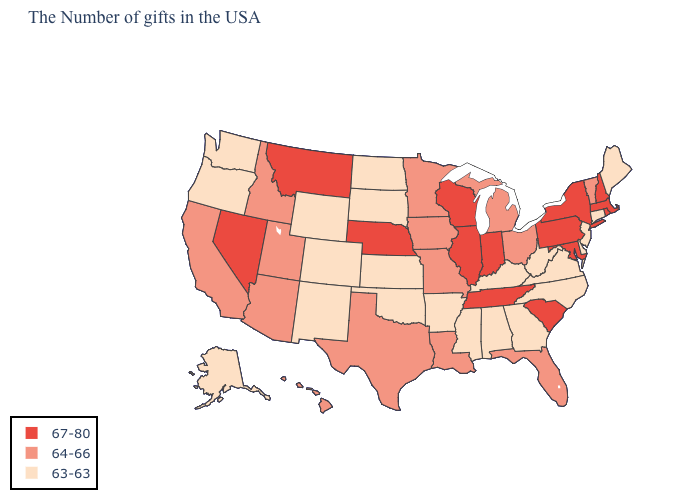What is the highest value in the USA?
Concise answer only. 67-80. What is the lowest value in the USA?
Give a very brief answer. 63-63. What is the value of Delaware?
Answer briefly. 63-63. Name the states that have a value in the range 63-63?
Write a very short answer. Maine, Connecticut, New Jersey, Delaware, Virginia, North Carolina, West Virginia, Georgia, Kentucky, Alabama, Mississippi, Arkansas, Kansas, Oklahoma, South Dakota, North Dakota, Wyoming, Colorado, New Mexico, Washington, Oregon, Alaska. Among the states that border Oklahoma , does Arkansas have the highest value?
Keep it brief. No. How many symbols are there in the legend?
Write a very short answer. 3. Which states hav the highest value in the West?
Write a very short answer. Montana, Nevada. Does Minnesota have the same value as Idaho?
Answer briefly. Yes. Name the states that have a value in the range 67-80?
Quick response, please. Massachusetts, Rhode Island, New Hampshire, New York, Maryland, Pennsylvania, South Carolina, Indiana, Tennessee, Wisconsin, Illinois, Nebraska, Montana, Nevada. Name the states that have a value in the range 64-66?
Short answer required. Vermont, Ohio, Florida, Michigan, Louisiana, Missouri, Minnesota, Iowa, Texas, Utah, Arizona, Idaho, California, Hawaii. What is the value of Alaska?
Give a very brief answer. 63-63. What is the value of Georgia?
Keep it brief. 63-63. Name the states that have a value in the range 64-66?
Keep it brief. Vermont, Ohio, Florida, Michigan, Louisiana, Missouri, Minnesota, Iowa, Texas, Utah, Arizona, Idaho, California, Hawaii. Does the first symbol in the legend represent the smallest category?
Answer briefly. No. Does the first symbol in the legend represent the smallest category?
Short answer required. No. 